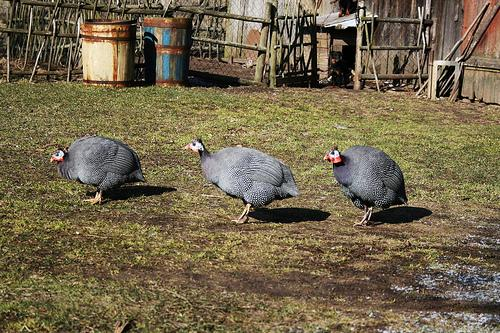Count the number of wooden poles and posts in the image. There are a total of two wooden poles and one wooden post in the image. Briefly describe the environment where the animals are located in this image. The animals are in a grassy area with patches of mud, surrounded by wooden fences, mesh wire fences, and an open gate. What are the turkeys searching for in the image? The turkeys are looking for food, possibly hunting for worms. What kind of interaction can be observed between the birds in the image? The birds are following each other and staying close together, possibly looking for food or watching out for predators. Based on the image, where are the turkeys located? The turkeys are in a backyard on a farm. Analyze the sentiment, or mood, evoked by the image. The image portrays a lively and natural outdoor scene, evoking a sense of curiosity and peacefulness as the birds traverse their rustic surroundings. Identify the different types of fences present in the image. There are wooden poles, a mesh wire fence, and a wooden fence in the image. What are the three main animals in the image? Three guinea hens and three turkeys are the main animals in the image. How many trash cans can be seen in the image and what is their condition? There are two trash cans in the image, and they are rusty. What are some features of the guinea hens in this image? The guinea hens have red on their heads, grey wings and bodies, white faces, and orangish-tan feet. Are there only one ginney chicken in the photo? The image captions mention there are three guinea chickens, stating that there is only one would be misleading. Are the wooden poles made of metal in the photo? The image captions describe the poles as wooden, so suggesting they are made of metal would be misleading. Is there no visible grass in the photo? The image captions mention grass in the photo, so suggesting there is no visible grass would be misleading. Do the turkeys have no colorful plumage? The captions mention that the turkeys all have colorful plumage, so claiming that they have no colorful plumage would be misleading. Are the trash cans in perfect condition and not rusty? The image captions explicitly state that the trash cans are rusty, so saying they are in perfect condition would be misleading. Are the guinea hens completely blue in color? The image captions mention that guinea hens have red on their heads, grey wings and bodies, white on their face, and orangish tan feet, but there is no mention of them being completely blue. 